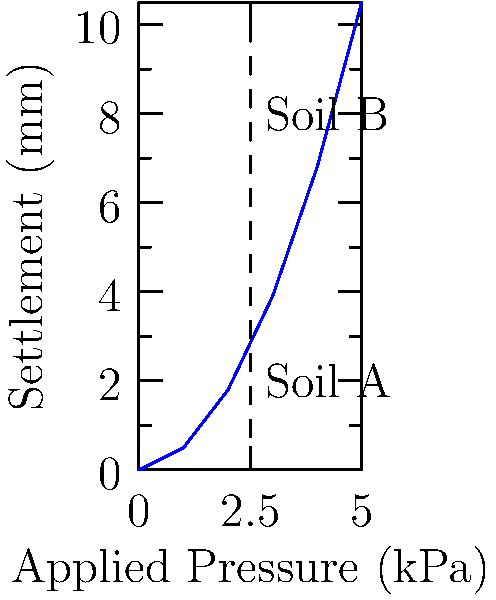A foundation is to be built on two different soil types, A and B, as shown in the pressure-settlement graph. If the allowable settlement is 5 mm, what is the maximum allowable applied pressure (in kPa) for Soil A? To solve this problem, we need to follow these steps:

1. Identify the curve representing Soil A on the graph. It's the lower curve.

2. Locate the point on Soil A's curve corresponding to 5 mm settlement on the y-axis.

3. From this point, draw an imaginary horizontal line to the x-axis to find the corresponding applied pressure.

4. Read the value on the x-axis where this imaginary line intersects.

Looking at the graph:

- The 5 mm settlement line intersects Soil A's curve at approximately 3.2 kPa on the x-axis.

Therefore, the maximum allowable applied pressure for Soil A, given an allowable settlement of 5 mm, is approximately 3.2 kPa.

This approach uses the graphical method to determine the allowable bearing capacity based on settlement criteria, which is crucial in foundation design to prevent excessive settlement that could damage structures.
Answer: 3.2 kPa 